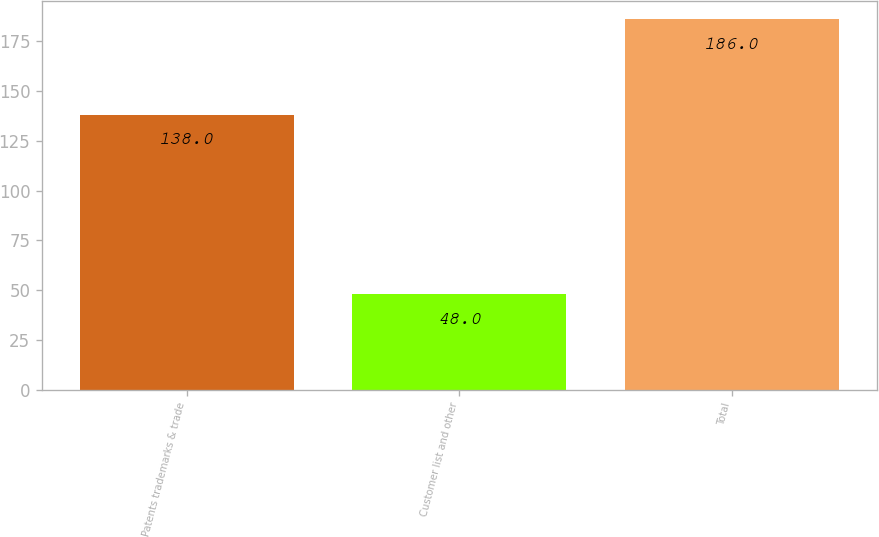Convert chart. <chart><loc_0><loc_0><loc_500><loc_500><bar_chart><fcel>Patents trademarks & trade<fcel>Customer list and other<fcel>Total<nl><fcel>138<fcel>48<fcel>186<nl></chart> 